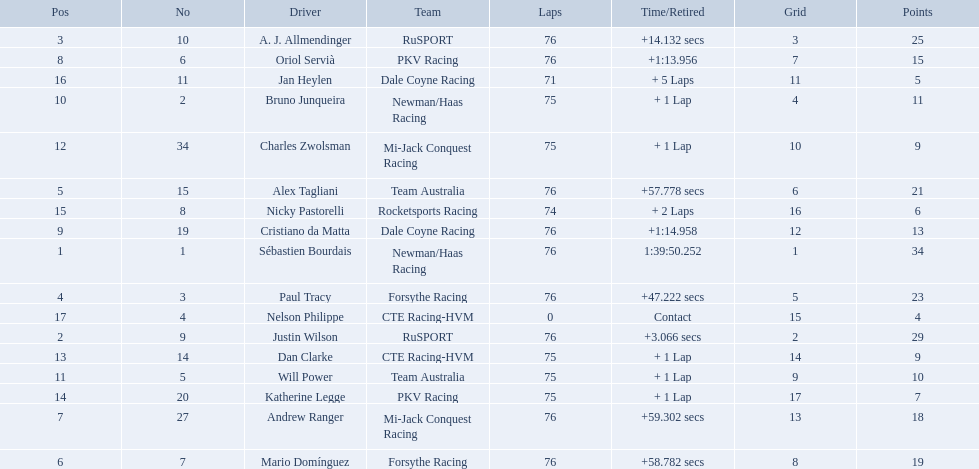How many points did charles zwolsman acquire? 9. Who else got 9 points? Dan Clarke. 